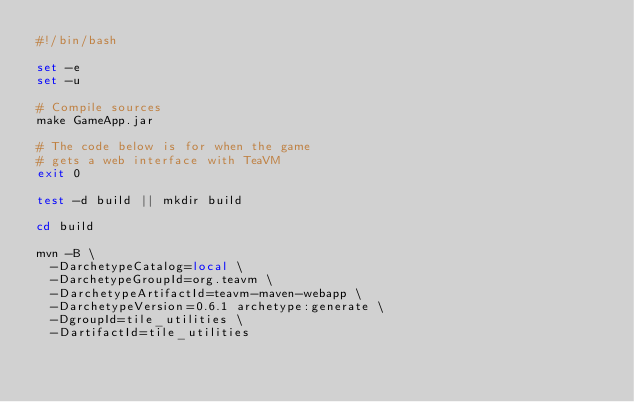Convert code to text. <code><loc_0><loc_0><loc_500><loc_500><_Bash_>#!/bin/bash

set -e
set -u

# Compile sources
make GameApp.jar

# The code below is for when the game
# gets a web interface with TeaVM
exit 0

test -d build || mkdir build

cd build

mvn -B \
  -DarchetypeCatalog=local \
  -DarchetypeGroupId=org.teavm \
  -DarchetypeArtifactId=teavm-maven-webapp \
  -DarchetypeVersion=0.6.1 archetype:generate \
  -DgroupId=tile_utilities \
  -DartifactId=tile_utilities
</code> 